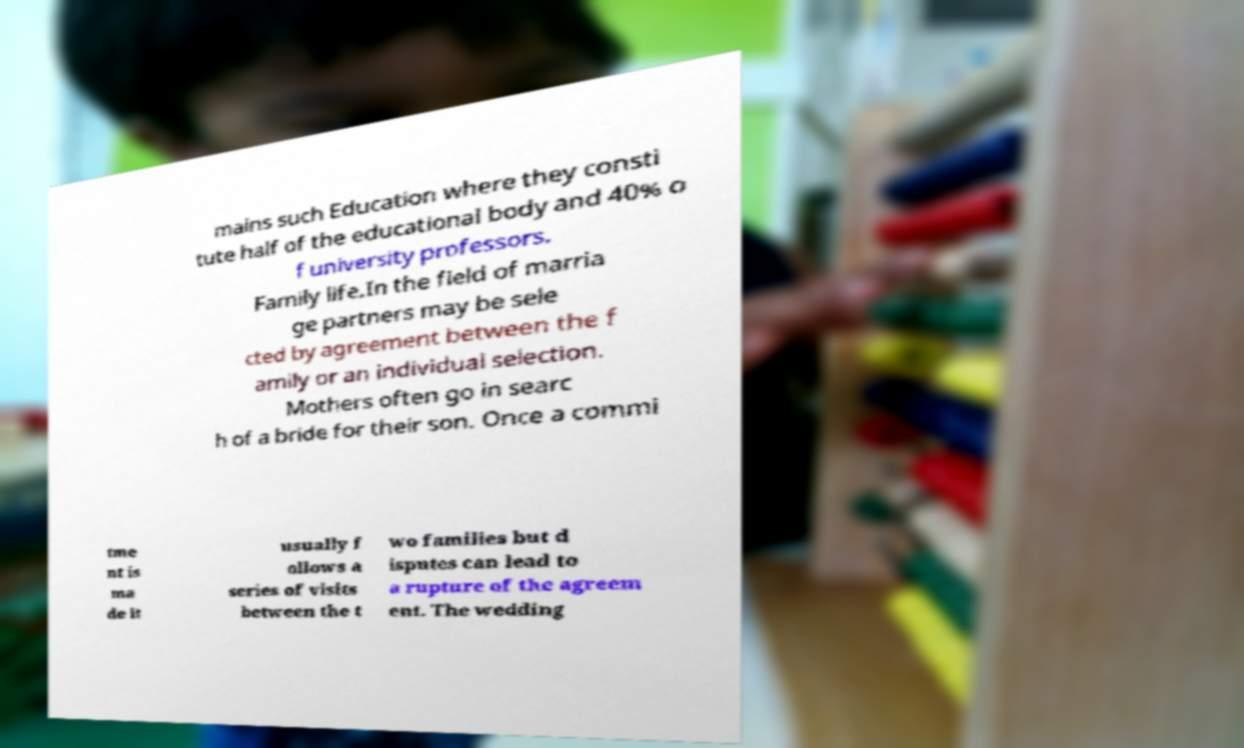I need the written content from this picture converted into text. Can you do that? mains such Education where they consti tute half of the educational body and 40% o f university professors. Family life.In the field of marria ge partners may be sele cted by agreement between the f amily or an individual selection. Mothers often go in searc h of a bride for their son. Once a commi tme nt is ma de it usually f ollows a series of visits between the t wo families but d isputes can lead to a rupture of the agreem ent. The wedding 